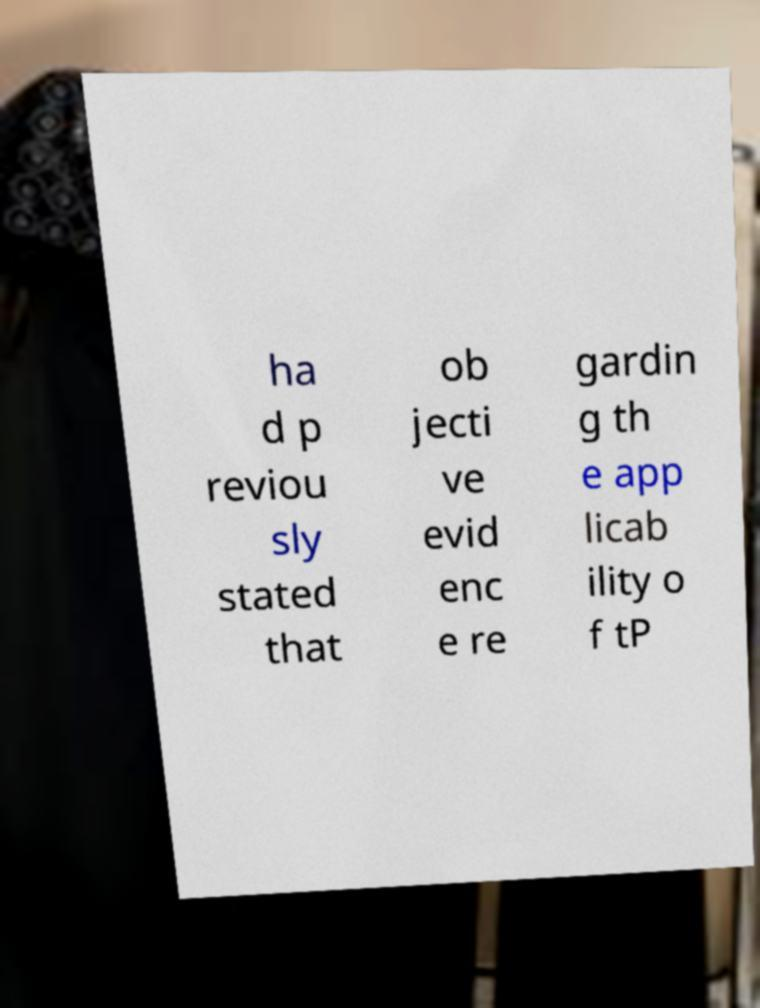Please read and relay the text visible in this image. What does it say? ha d p reviou sly stated that ob jecti ve evid enc e re gardin g th e app licab ility o f tP 